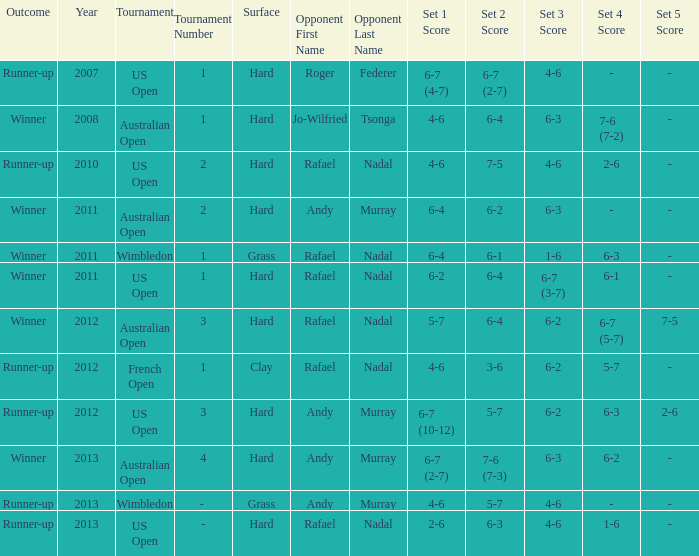What surface was the Australian Open (1) played on? Hard. 